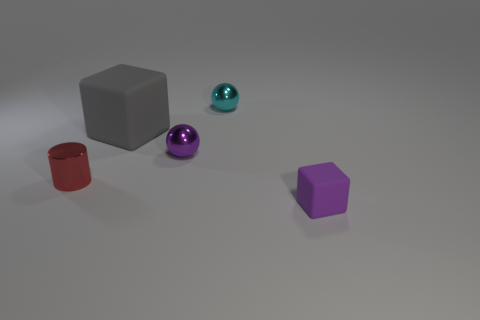Add 1 large green matte spheres. How many objects exist? 6 Subtract all small green matte cubes. Subtract all gray rubber things. How many objects are left? 4 Add 1 small red metal things. How many small red metal things are left? 2 Add 3 purple metallic things. How many purple metallic things exist? 4 Subtract 0 green cubes. How many objects are left? 5 Subtract all cubes. How many objects are left? 3 